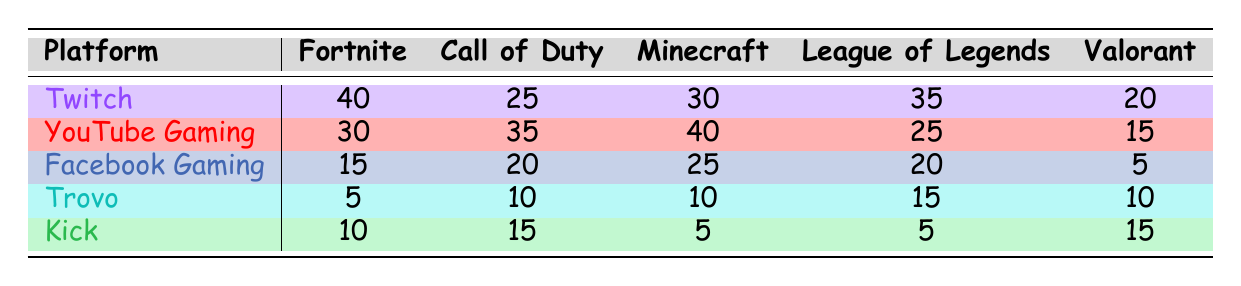What platform has the highest usage for Fortnite? By looking at the Fortnite column, I can see that Twitch has the highest number with 40. Other platforms have lower numbers: YouTube Gaming has 30, Facebook Gaming has 15, Trovo has 5, and Kick has 10.
Answer: Twitch What is the total usage for Minecraft across all platforms? To find the total usage for Minecraft, I need to add the usage numbers from each platform: 30 (Twitch) + 40 (YouTube Gaming) + 25 (Facebook Gaming) + 10 (Trovo) + 5 (Kick) = 110.
Answer: 110 Did Facebook Gaming have a higher usage for Call of Duty than Trovo? Looking at the Call of Duty row, Facebook Gaming has 20 and Trovo has 10. Since 20 is greater than 10, the statement is true.
Answer: Yes What platform has the least usage for League of Legends? Checking the League of Legends column, I see that both Kick and Facebook Gaming have the lowest value at 5 and 20, respectively. Since 5 (Kick) is lower than 20 (Facebook Gaming), Kick is the answer.
Answer: Kick What is the average usage of Valorant across all platforms? To calculate the average, I first sum the Valorant usage: 20 (Twitch) + 15 (YouTube Gaming) + 5 (Facebook Gaming) + 10 (Trovo) + 15 (Kick) = 75. There are 5 platforms, so I divide 75 by 5, which gives 15.
Answer: 15 Which game had the highest total usage across all platforms? I need to add up the usage for each game: Fortnite (40 + 30 + 15 + 5 + 10 = 100), Call of Duty (25 + 35 + 20 + 10 + 15 = 105), Minecraft (30 + 40 + 25 + 10 + 5 = 110), League of Legends (35 + 25 + 20 + 15 + 5 = 100), and Valorant (20 + 15 + 5 + 10 + 15 = 75). Minecraft has the highest total usage at 110.
Answer: Minecraft Is Twitch the preferred platform for any game? By comparing the values in each row, I see that Twitch has the highest number for Fortnite (40), League of Legends (35), and Minecraft (30) compared to other platforms. Therefore, it is preferred for these games.
Answer: Yes What is the difference in usage for Call of Duty between YouTube Gaming and Kick? To find the difference, I subtract the usage numbers: YouTube Gaming has 35 and Kick has 15. So, 35 - 15 = 20.
Answer: 20 